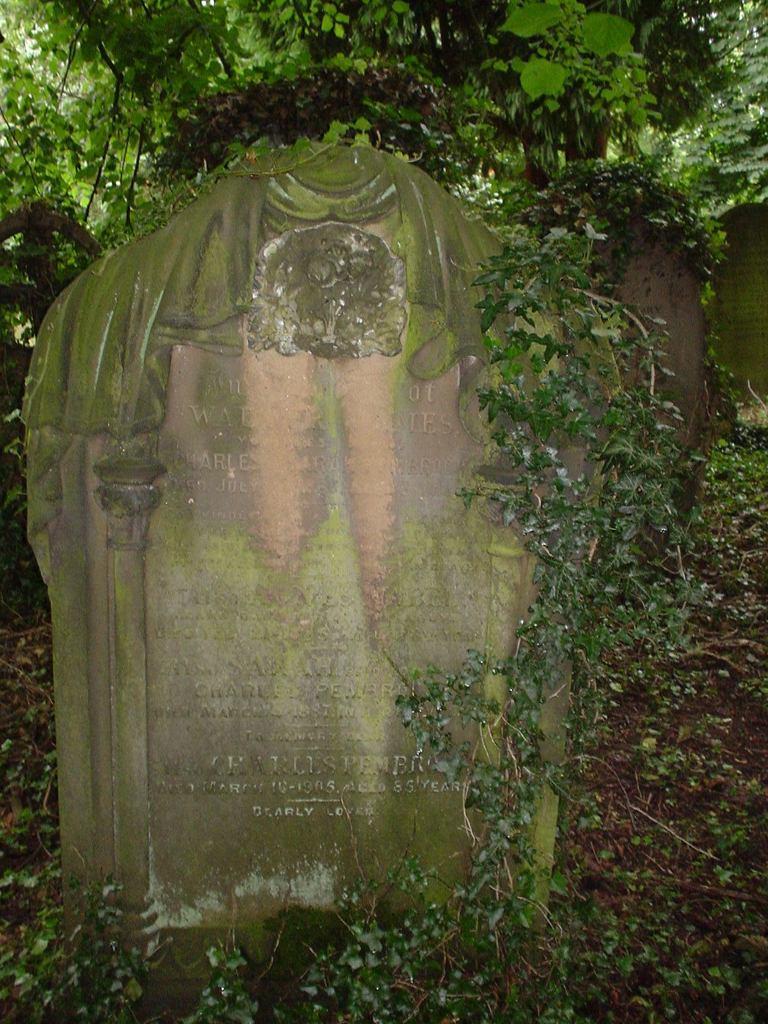Please provide a concise description of this image. In this image there is a stone on that there is some text, in the background there are plants. 